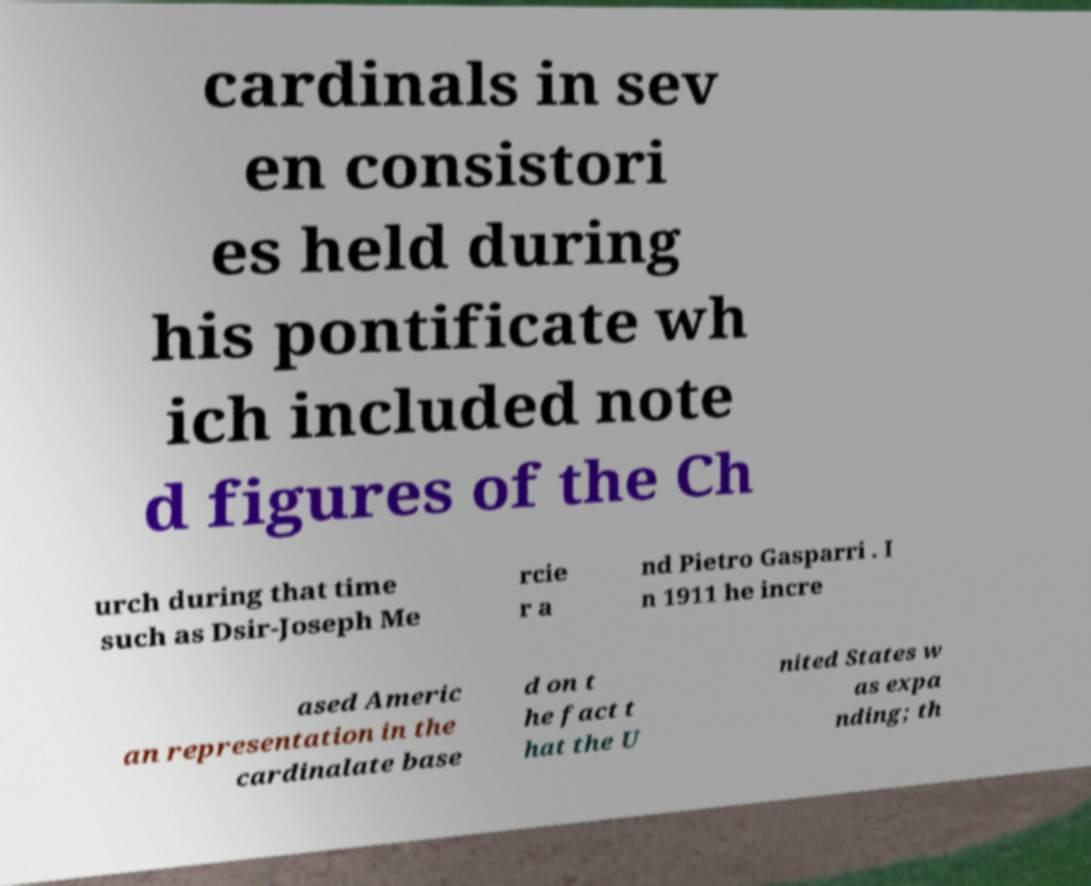There's text embedded in this image that I need extracted. Can you transcribe it verbatim? cardinals in sev en consistori es held during his pontificate wh ich included note d figures of the Ch urch during that time such as Dsir-Joseph Me rcie r a nd Pietro Gasparri . I n 1911 he incre ased Americ an representation in the cardinalate base d on t he fact t hat the U nited States w as expa nding; th 